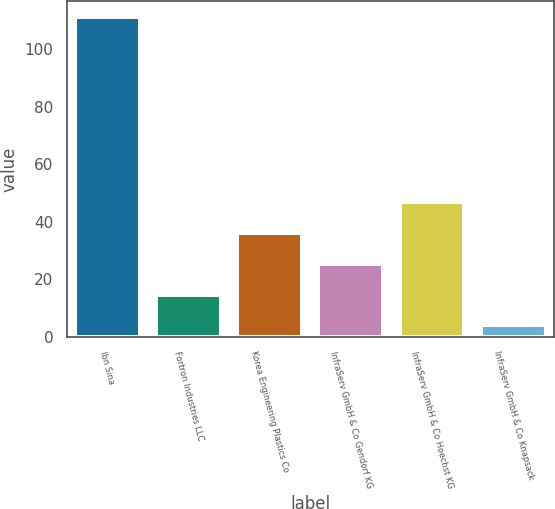<chart> <loc_0><loc_0><loc_500><loc_500><bar_chart><fcel>Ibn Sina<fcel>Fortron Industries LLC<fcel>Korea Engineering Plastics Co<fcel>InfraServ GmbH & Co Gendorf KG<fcel>InfraServ GmbH & Co Hoechst KG<fcel>InfraServ GmbH & Co Knapsack<nl><fcel>111<fcel>14.7<fcel>36.1<fcel>25.4<fcel>46.8<fcel>4<nl></chart> 